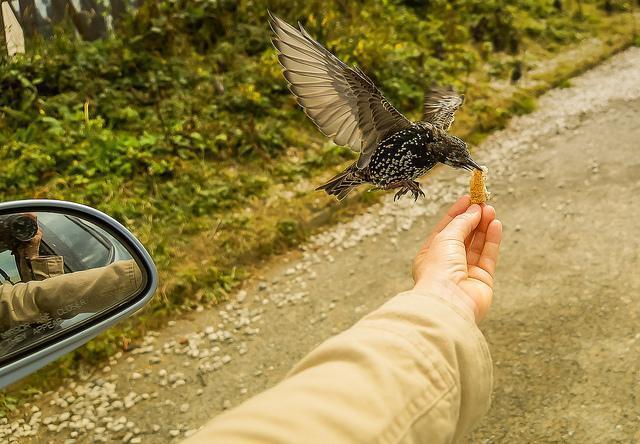How many people are in the photo?
Give a very brief answer. 1. How many street signs with a horse in it?
Give a very brief answer. 0. 